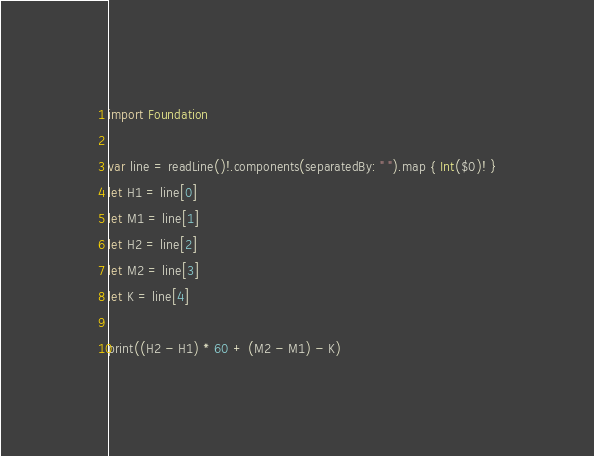<code> <loc_0><loc_0><loc_500><loc_500><_Swift_>import Foundation

var line = readLine()!.components(separatedBy: " ").map { Int($0)! }
let H1 = line[0]
let M1 = line[1]
let H2 = line[2]
let M2 = line[3]
let K = line[4]

print((H2 - H1) * 60 + (M2 - M1) - K)</code> 